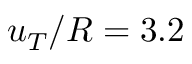Convert formula to latex. <formula><loc_0><loc_0><loc_500><loc_500>u _ { T } / R = 3 . 2</formula> 